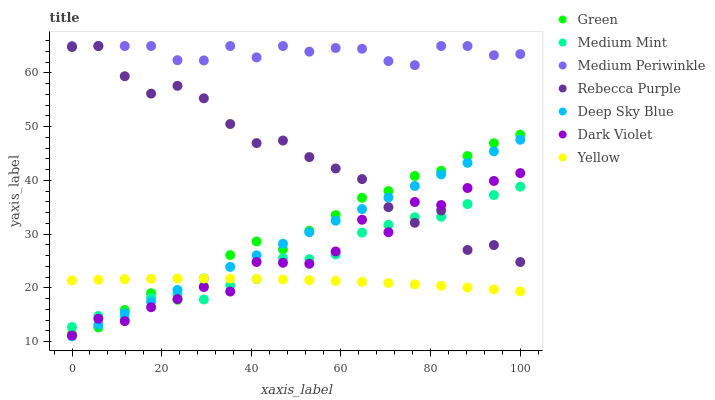Does Yellow have the minimum area under the curve?
Answer yes or no. Yes. Does Medium Periwinkle have the maximum area under the curve?
Answer yes or no. Yes. Does Dark Violet have the minimum area under the curve?
Answer yes or no. No. Does Dark Violet have the maximum area under the curve?
Answer yes or no. No. Is Deep Sky Blue the smoothest?
Answer yes or no. Yes. Is Rebecca Purple the roughest?
Answer yes or no. Yes. Is Medium Periwinkle the smoothest?
Answer yes or no. No. Is Medium Periwinkle the roughest?
Answer yes or no. No. Does Deep Sky Blue have the lowest value?
Answer yes or no. Yes. Does Dark Violet have the lowest value?
Answer yes or no. No. Does Rebecca Purple have the highest value?
Answer yes or no. Yes. Does Dark Violet have the highest value?
Answer yes or no. No. Is Dark Violet less than Medium Periwinkle?
Answer yes or no. Yes. Is Medium Periwinkle greater than Medium Mint?
Answer yes or no. Yes. Does Green intersect Medium Mint?
Answer yes or no. Yes. Is Green less than Medium Mint?
Answer yes or no. No. Is Green greater than Medium Mint?
Answer yes or no. No. Does Dark Violet intersect Medium Periwinkle?
Answer yes or no. No. 